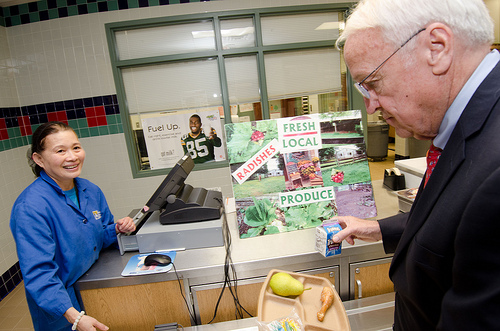<image>
Is the box on the table? No. The box is not positioned on the table. They may be near each other, but the box is not supported by or resting on top of the table. Is the radishes above the tray? No. The radishes is not positioned above the tray. The vertical arrangement shows a different relationship. 